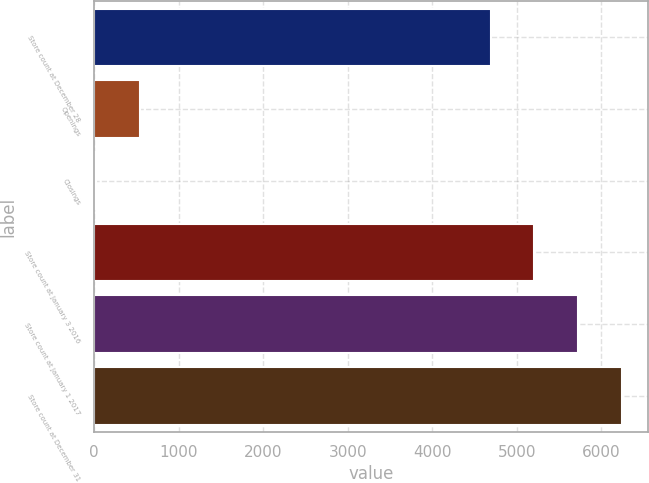Convert chart. <chart><loc_0><loc_0><loc_500><loc_500><bar_chart><fcel>Store count at December 28<fcel>Openings<fcel>Closings<fcel>Store count at January 3 2016<fcel>Store count at January 1 2017<fcel>Store count at December 31<nl><fcel>4690<fcel>542.9<fcel>26<fcel>5206.9<fcel>5723.8<fcel>6240.7<nl></chart> 